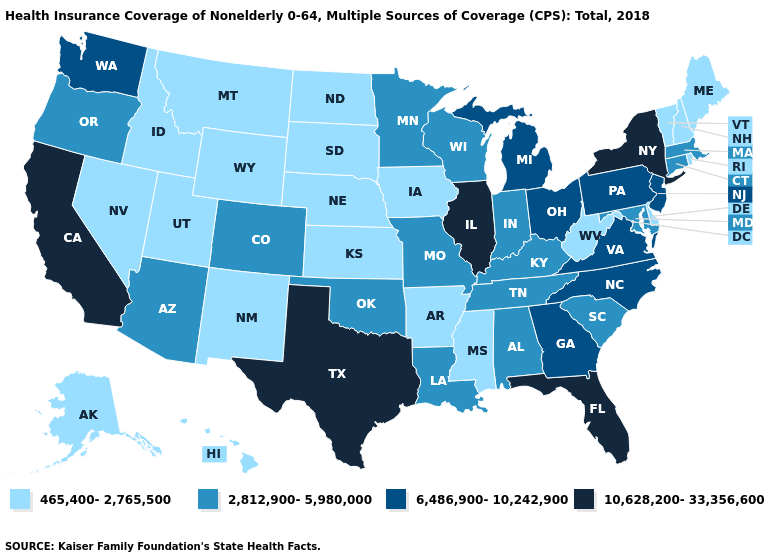Name the states that have a value in the range 2,812,900-5,980,000?
Keep it brief. Alabama, Arizona, Colorado, Connecticut, Indiana, Kentucky, Louisiana, Maryland, Massachusetts, Minnesota, Missouri, Oklahoma, Oregon, South Carolina, Tennessee, Wisconsin. Does Minnesota have the lowest value in the MidWest?
Give a very brief answer. No. Name the states that have a value in the range 10,628,200-33,356,600?
Write a very short answer. California, Florida, Illinois, New York, Texas. Among the states that border Utah , which have the highest value?
Quick response, please. Arizona, Colorado. How many symbols are there in the legend?
Quick response, please. 4. Name the states that have a value in the range 6,486,900-10,242,900?
Be succinct. Georgia, Michigan, New Jersey, North Carolina, Ohio, Pennsylvania, Virginia, Washington. Which states hav the highest value in the West?
Keep it brief. California. What is the lowest value in the South?
Quick response, please. 465,400-2,765,500. Which states have the lowest value in the USA?
Keep it brief. Alaska, Arkansas, Delaware, Hawaii, Idaho, Iowa, Kansas, Maine, Mississippi, Montana, Nebraska, Nevada, New Hampshire, New Mexico, North Dakota, Rhode Island, South Dakota, Utah, Vermont, West Virginia, Wyoming. Among the states that border Indiana , does Illinois have the lowest value?
Quick response, please. No. Name the states that have a value in the range 6,486,900-10,242,900?
Keep it brief. Georgia, Michigan, New Jersey, North Carolina, Ohio, Pennsylvania, Virginia, Washington. What is the value of Wisconsin?
Be succinct. 2,812,900-5,980,000. What is the value of South Carolina?
Concise answer only. 2,812,900-5,980,000. Does South Dakota have the lowest value in the USA?
Write a very short answer. Yes. What is the lowest value in the USA?
Short answer required. 465,400-2,765,500. 